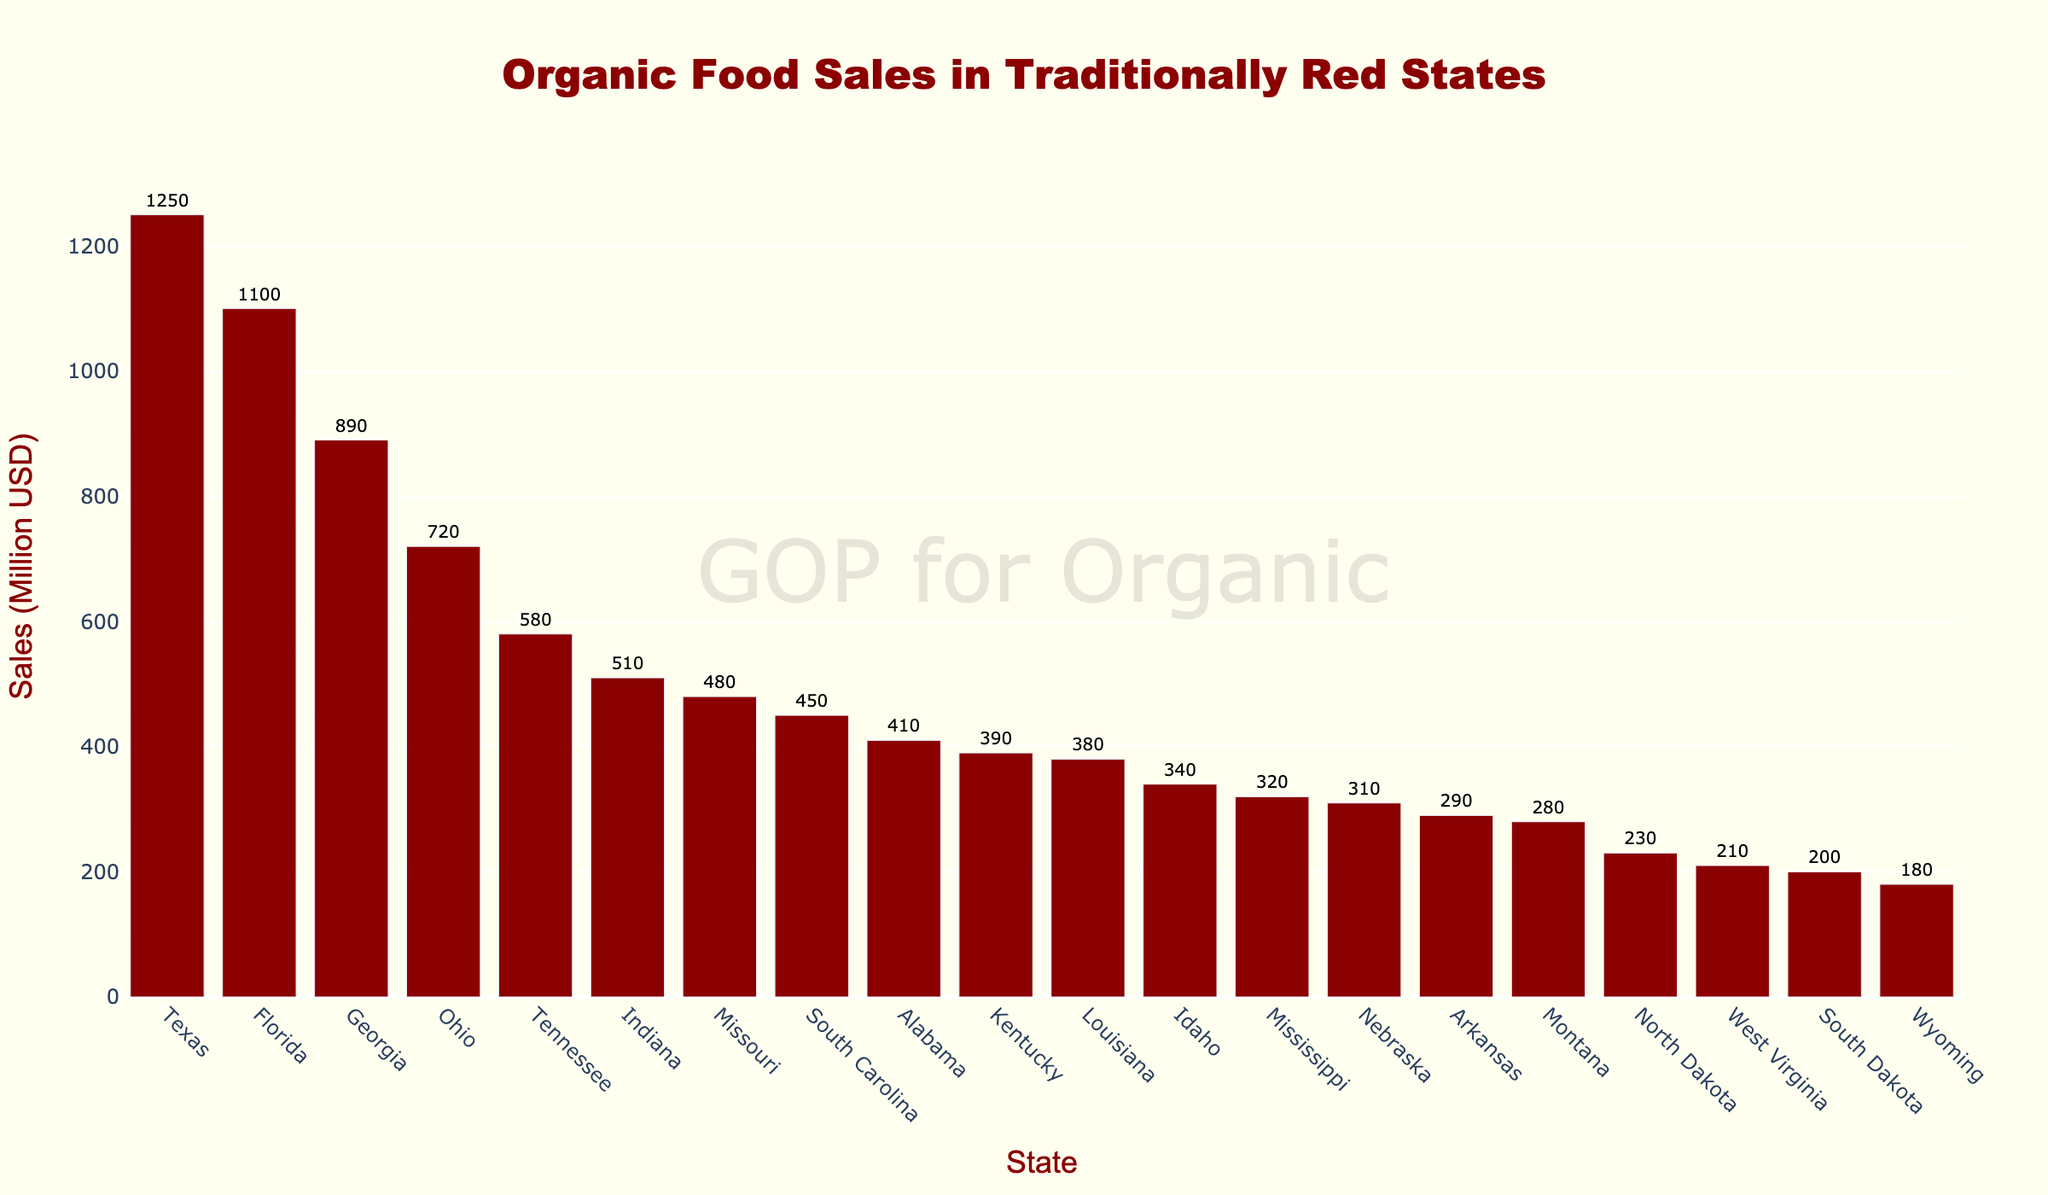Which state has the highest organic food sales? In the bar chart, the bar of Texas is the tallest, indicating that it has the highest sales figure.
Answer: Texas What is the difference in organic food sales between Texas and Georgia? Texas has sales of 1250 million USD and Georgia has 890 million USD. The difference is 1250 - 890.
Answer: 360 million USD Which three states have the lowest organic food sales, and what are their respective sales figures? The shortest bars represent the states with the lowest sales: Wyoming (180), South Dakota (200), and West Virginia (210).
Answer: Wyoming: 180M, South Dakota: 200M, West Virginia: 210M How does Florida's organic food sales compare to Ohio's? Florida has sales of 1100 million USD, while Ohio has 720 million USD. Florida's sales are higher.
Answer: Florida has higher sales What is the combined total sales of the three states with the highest organic food sales? The top three states are Texas (1250M), Florida (1100M), and Georgia (890M). Their combined total is 1250 + 1100 + 890.
Answer: 3240 million USD Are there any states with exactly the same organic food sales figures? The bars for Idaho (340M) and Nebraska (310M) show that no two states have identical sales figures.
Answer: No What is the average organic food sales figure across all the traditionally red states presented? Sum all sales: 1250 + 890 + 1100 + 720 + 580 + 510 + 480 + 410 + 390 + 450 + 320 + 380 + 290 + 210 + 340 + 280 + 180 + 230 + 200 + 310 = 8990. Divide by 20 states.
Answer: 449.5 million USD How do Missouri's organic food sales compare to those of Tennessee? Which state sells more? Missouri has sales of 480 million USD, and Tennessee has 580 million USD. Tennessee's sales are higher.
Answer: Tennessee sells more If we add the organic food sales of the five states with the lowest sales, what is the total? The states are Wyoming (180), South Dakota (200), West Virginia (210), Arkansas (290), and Mississippi (320). Total = 180 + 200 + 210 + 290 + 320.
Answer: 1200 million USD 